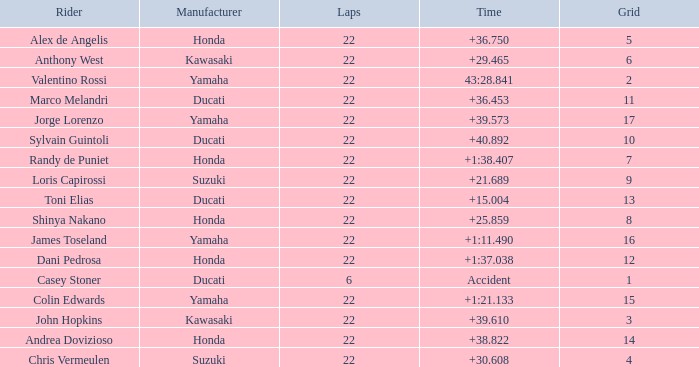What grid is Ducati with fewer than 22 laps? 1.0. 